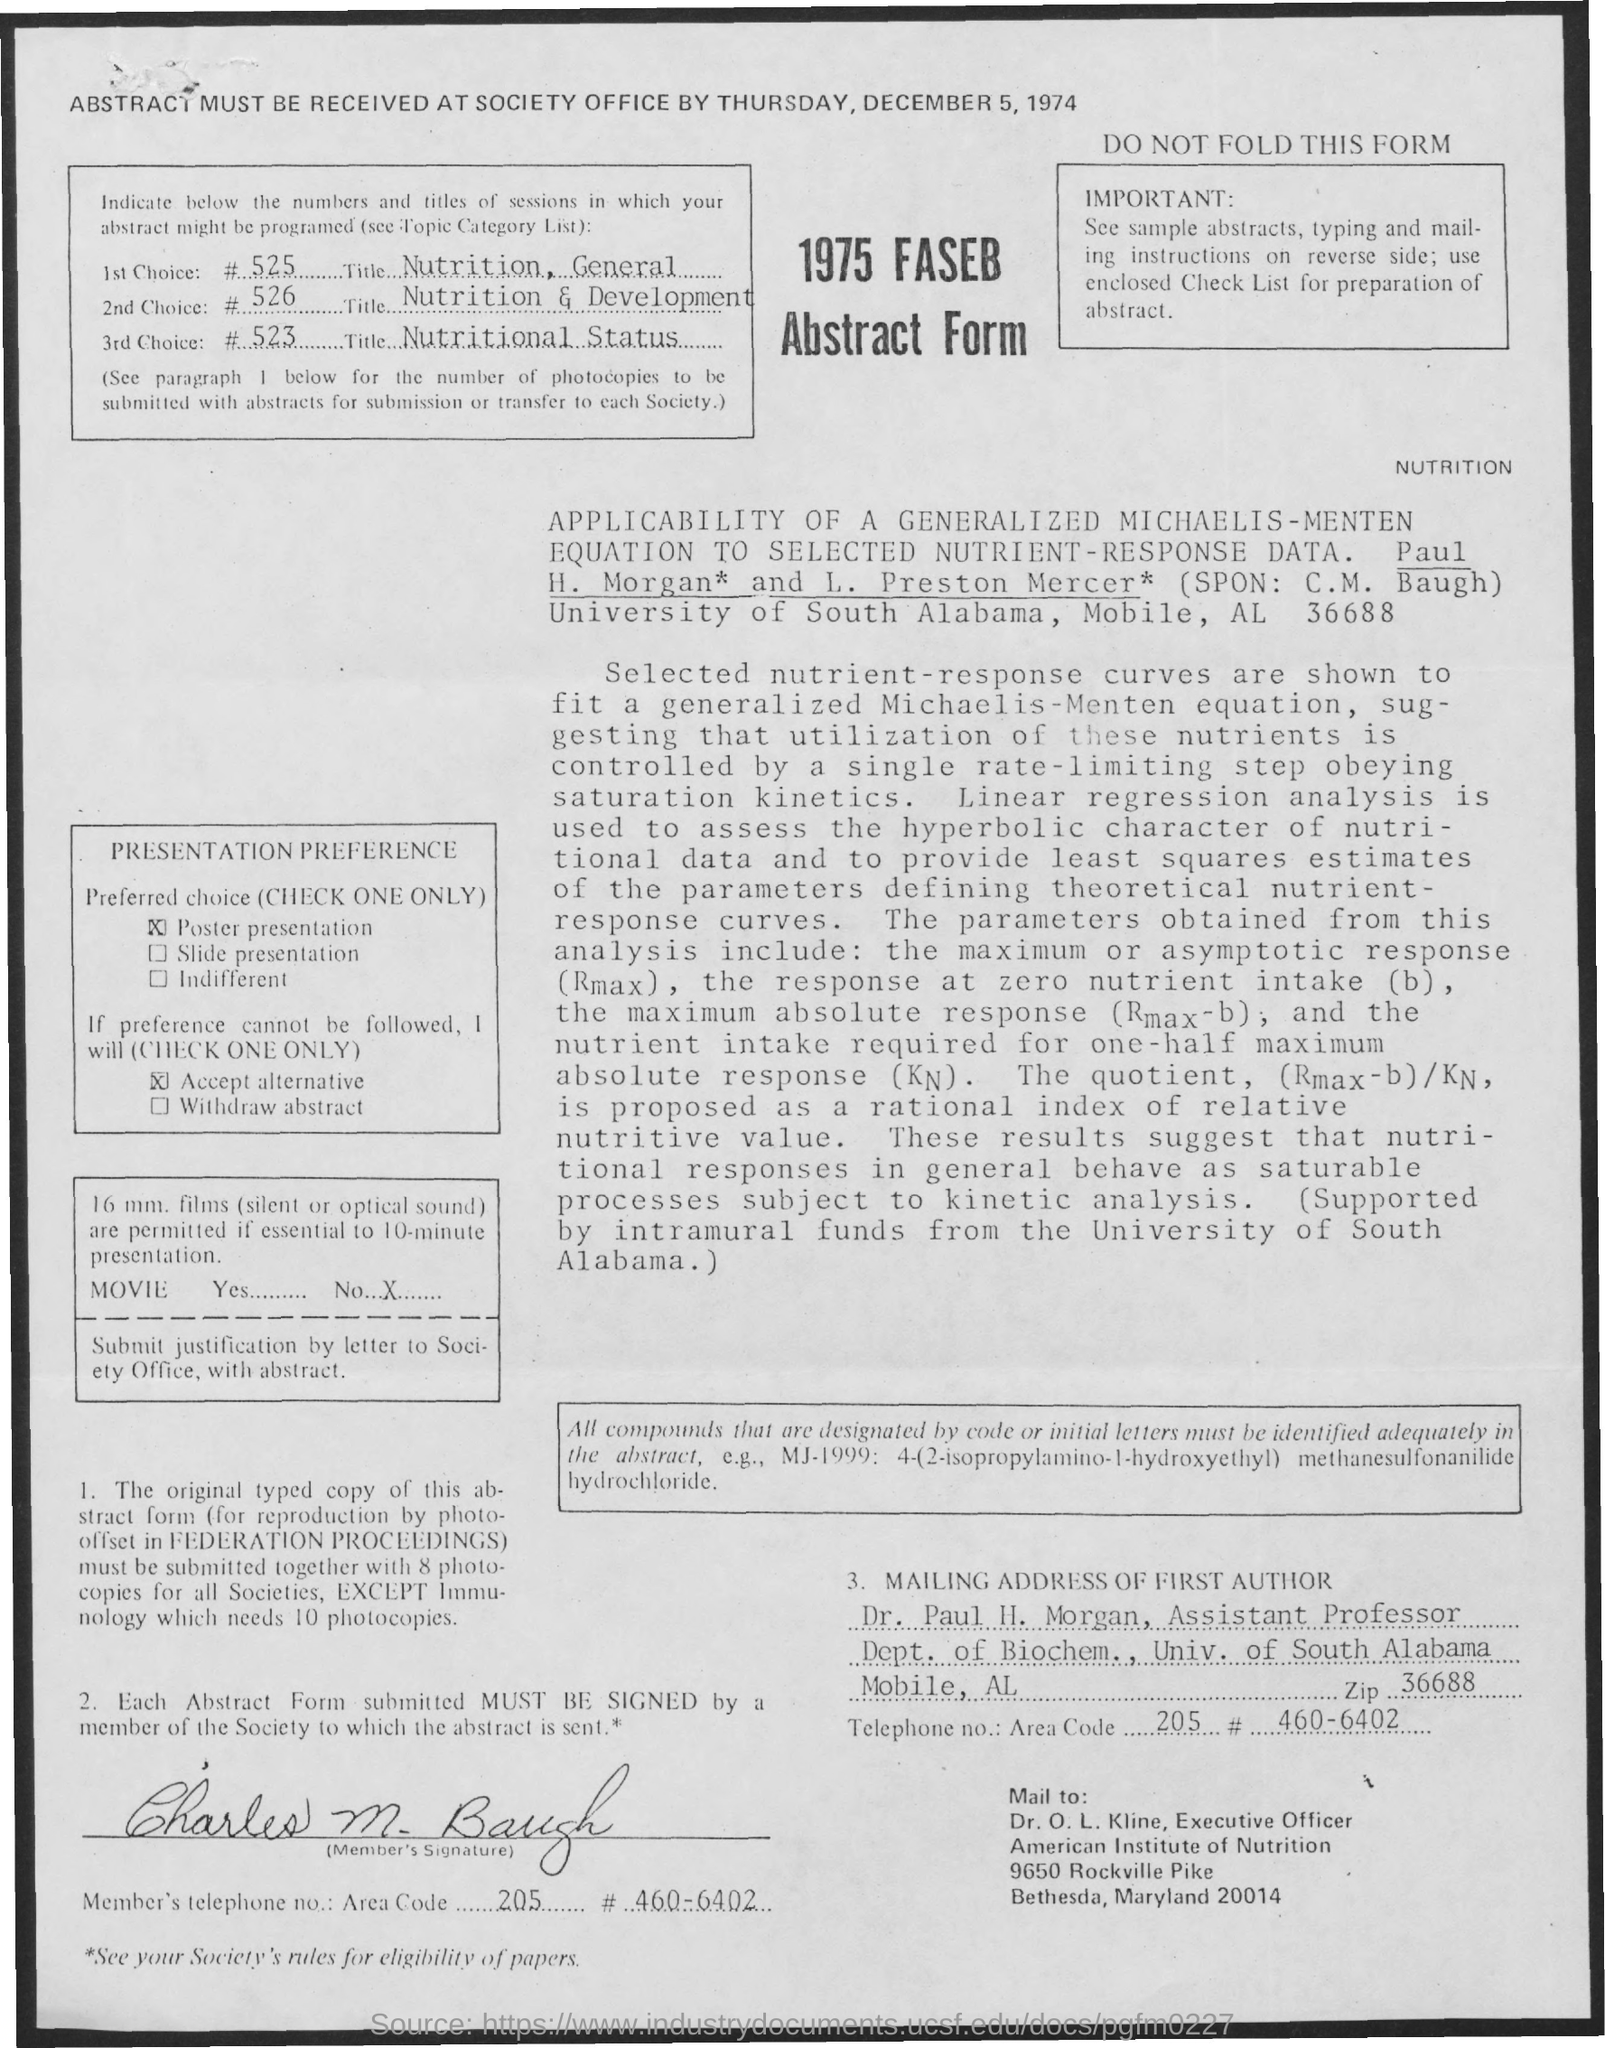On what date the abstract must be received?
Your response must be concise. THURSDAY, DECEMBER 5, 1974. What is title of 1st Choice?
Your response must be concise. NUTRITION, GENERAL. What is title of 2nd Choice?
Your answer should be very brief. NUTRITION AND DEVELOPMENT. What is title of 3rd Choice?
Your answer should be very brief. NUTRITIONAL STATUS. 